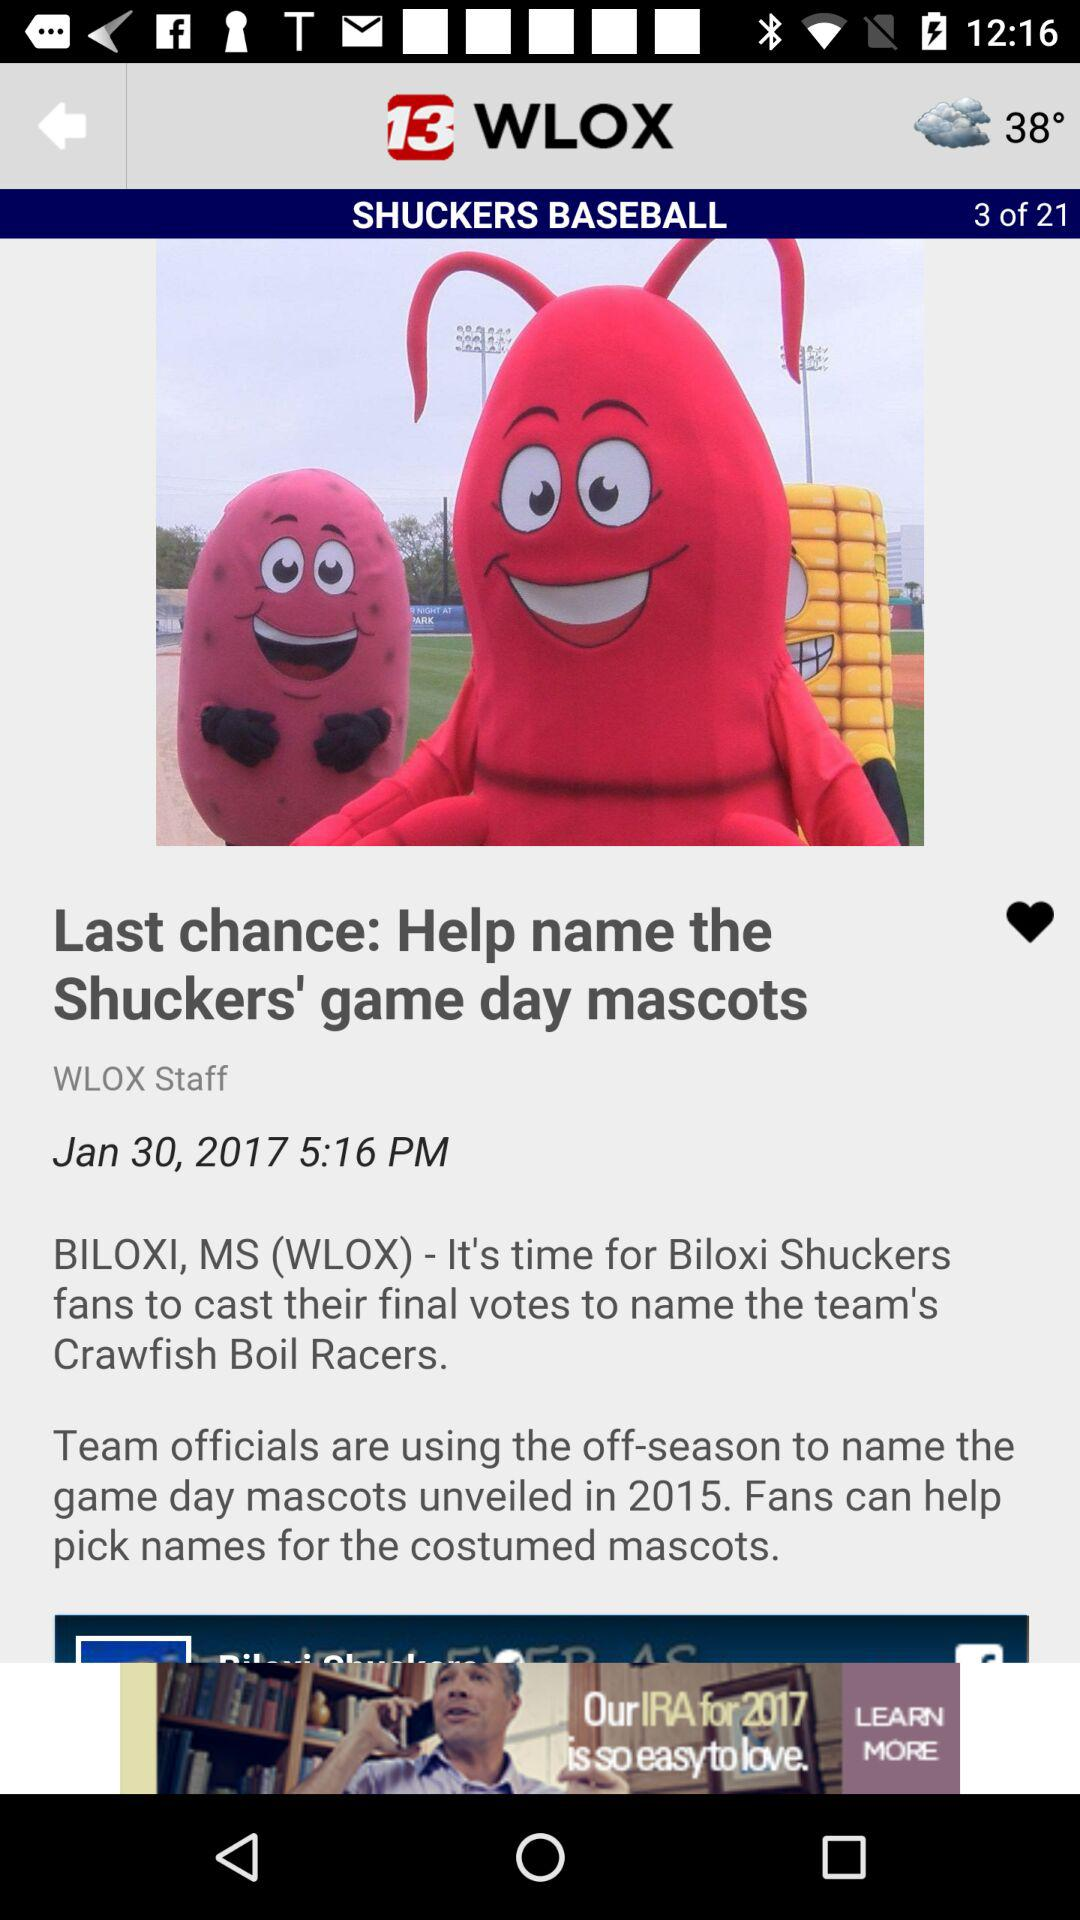What is the time? The time is 5:16 p.m. 